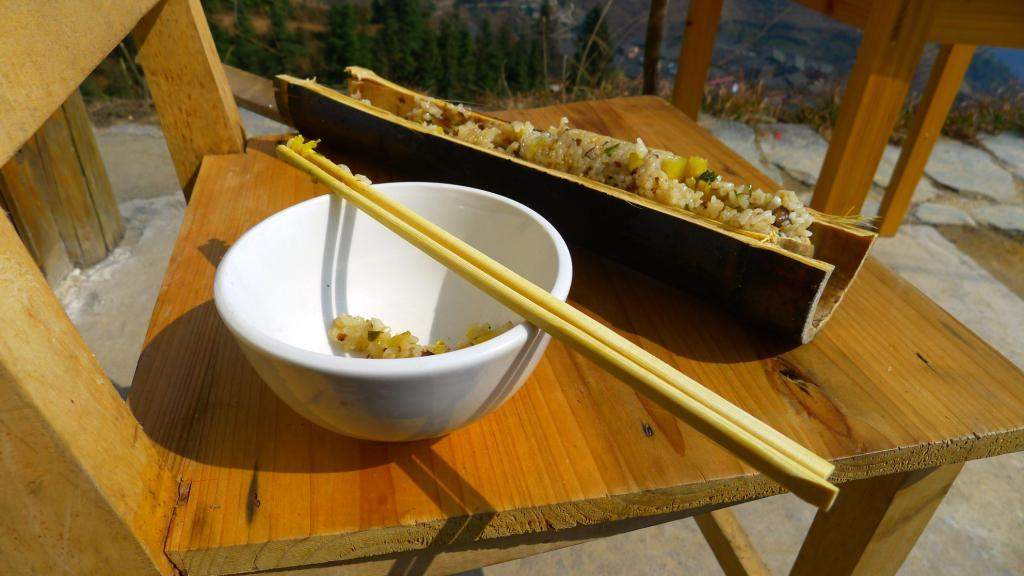What type of furniture is in the image? There is a chair in the image. What is placed on the chair? There is a white color bowl on the chair. What utensil is present on the chair? Chopsticks are present on the chair. What can be inferred about the presence of food in the image? Since there is a bowl and chopsticks on the chair, it is likely that there is food in the image. What type of advice does the father give to the person in the image? There is no father present in the image, so it is not possible to answer that question. 